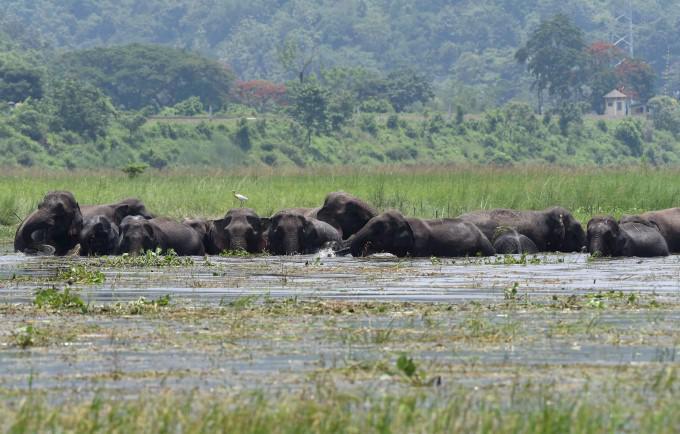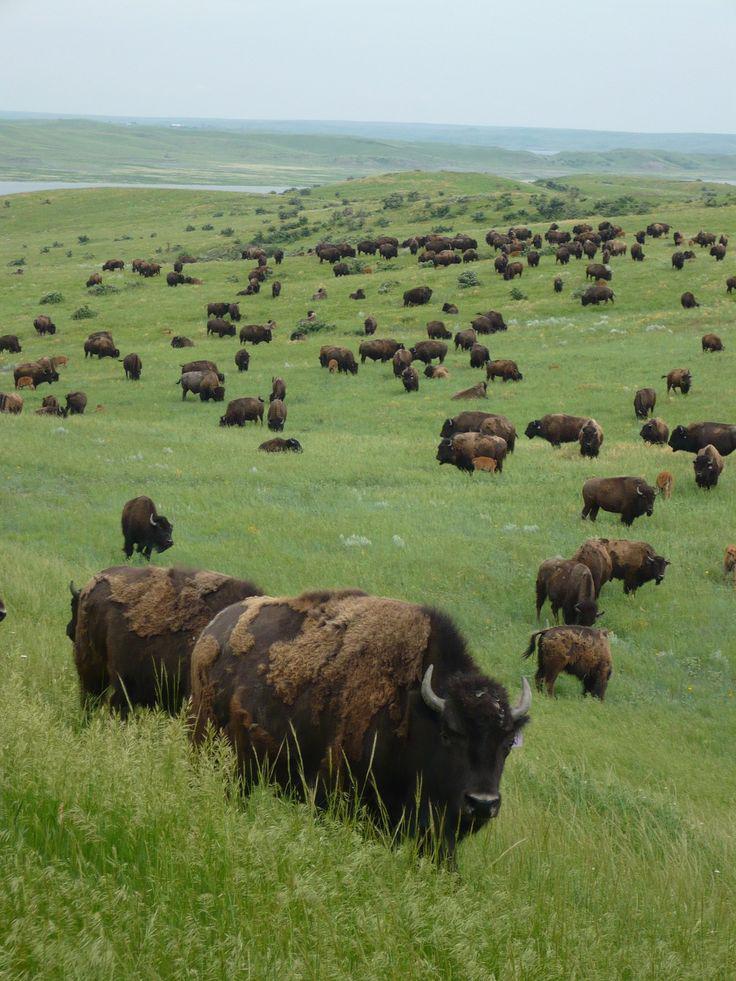The first image is the image on the left, the second image is the image on the right. For the images displayed, is the sentence "There are at least 4 black ox in the water that is landlocked by grass." factually correct? Answer yes or no. Yes. 